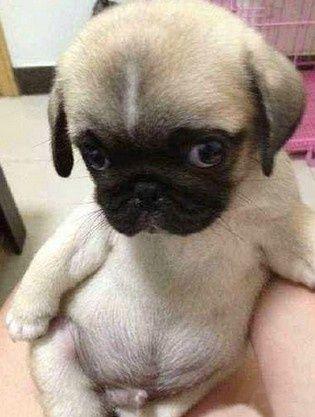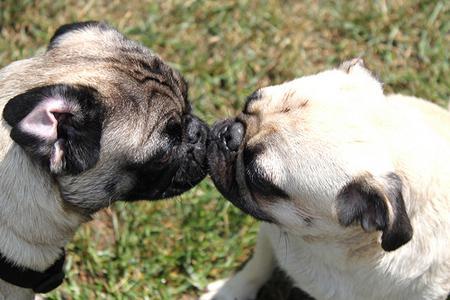The first image is the image on the left, the second image is the image on the right. For the images displayed, is the sentence "Two buff beige pugs with dark muzzles, at least one wearing a collar, are close together and face to face in the right image." factually correct? Answer yes or no. Yes. The first image is the image on the left, the second image is the image on the right. Evaluate the accuracy of this statement regarding the images: "Two dogs are outside in the grass in the image on the right.". Is it true? Answer yes or no. Yes. 